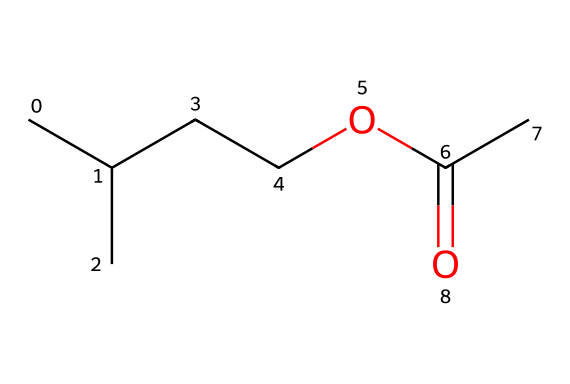What is the IUPAC name of this compound? The provided SMILES structure indicates that this molecule is an ester formed from isoamyl alcohol and acetic acid. The longest carbon chain connected to the ester functional group leads to the identification of this compound. It follows the naming convention for esters, which typically includes the alkyl part (from isoamyl) followed by the acid part (from acetic acid), leading to the name isoamyl acetate.
Answer: isoamyl acetate How many carbon atoms are in isoamyl acetate? Analyzing the SMILES representation, there are a total of 5 carbon atoms in the isoamyl part (CC(C)C) and 2 carbon atoms in the acetate part (C(C)=O), totaling 7 carbon atoms.
Answer: 7 What type of functional group is present in isoamyl acetate? The presence of the "C(C)=O" part of the SMILES indicates that this molecule contains a carbonyl group (C=O) connected to an oxygen, characteristic of esters. Therefore, the functional group is an ester functional group.
Answer: ester What is the total number of oxygen atoms in isoamyl acetate? The SMILES structure includes one oxygen in the ester functional group (between the carbon atoms) and one oxygen in the carbonyl (C=O), leading to a total of 2 oxygen atoms in the molecule.
Answer: 2 Does isoamyl acetate have any double bonds? Looking at the SMILES representation, the only double bond present is in the carbonyl group (C=O). Therefore, the compound contains one double bond.
Answer: yes What molecular feature gives isoamyl acetate its banana flavor? The branched carbon chain in isoamyl acetate mimics the molecular structure of certain natural compounds that produce a banana flavor. This specific arrangement is crucial for the flavor profile often associated with bananas.
Answer: branched carbon chain 